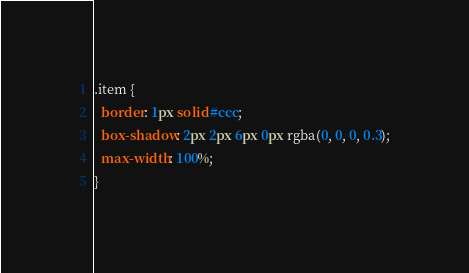<code> <loc_0><loc_0><loc_500><loc_500><_CSS_>.item {
  border: 1px solid #ccc;
  box-shadow: 2px 2px 6px 0px rgba(0, 0, 0, 0.3);
  max-width: 100%;
}
</code> 